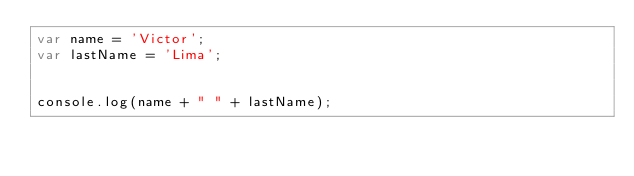Convert code to text. <code><loc_0><loc_0><loc_500><loc_500><_JavaScript_>var name = 'Victor';
var lastName = 'Lima';


console.log(name + " " + lastName);
</code> 